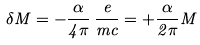Convert formula to latex. <formula><loc_0><loc_0><loc_500><loc_500>\delta M = - \frac { \alpha } { 4 \pi } \, \frac { e } { m c } = + \frac { \alpha } { 2 \pi } M</formula> 